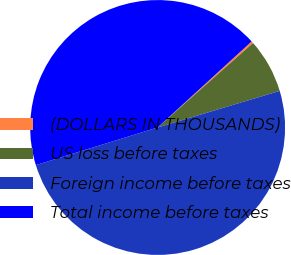<chart> <loc_0><loc_0><loc_500><loc_500><pie_chart><fcel>(DOLLARS IN THOUSANDS)<fcel>US loss before taxes<fcel>Foreign income before taxes<fcel>Total income before taxes<nl><fcel>0.26%<fcel>6.9%<fcel>49.87%<fcel>42.97%<nl></chart> 